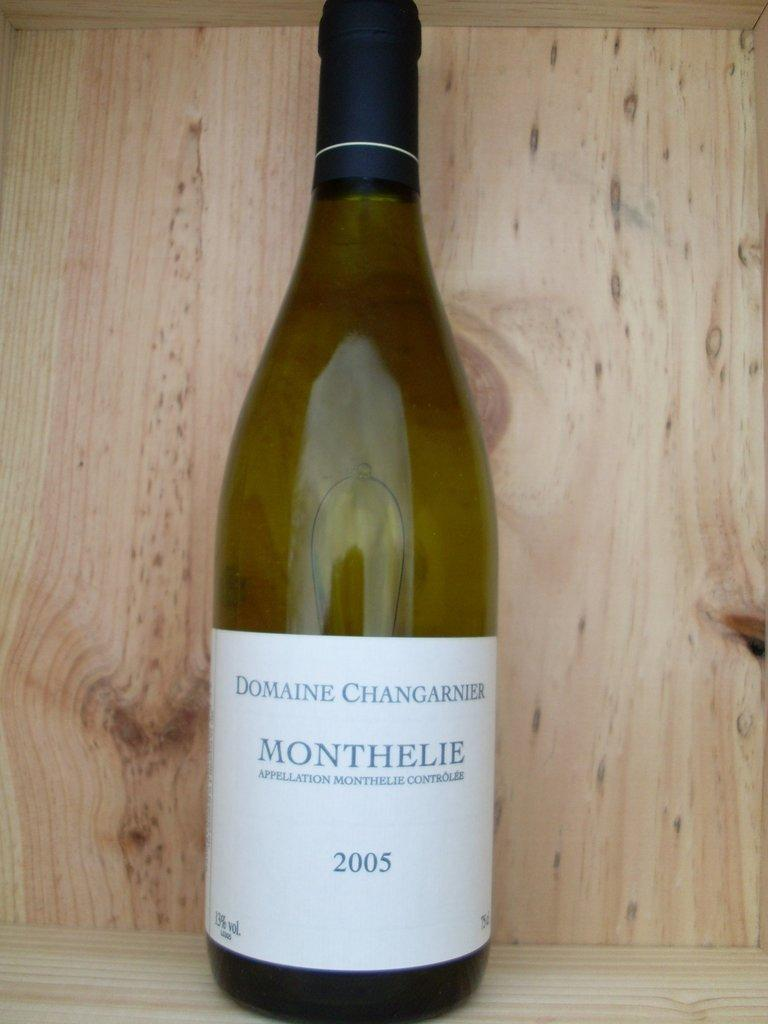<image>
Create a compact narrative representing the image presented. A bottle of Domine Changarnier Monthelie from 2005 is on a wooden shelf. 